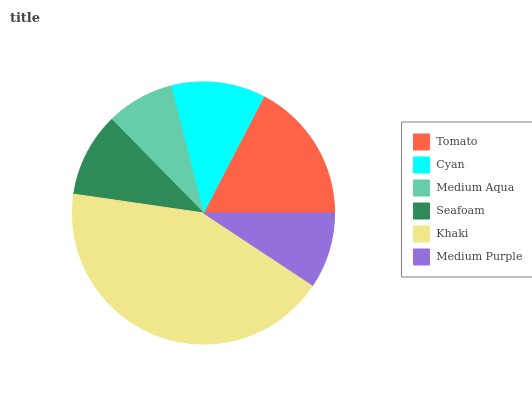Is Medium Aqua the minimum?
Answer yes or no. Yes. Is Khaki the maximum?
Answer yes or no. Yes. Is Cyan the minimum?
Answer yes or no. No. Is Cyan the maximum?
Answer yes or no. No. Is Tomato greater than Cyan?
Answer yes or no. Yes. Is Cyan less than Tomato?
Answer yes or no. Yes. Is Cyan greater than Tomato?
Answer yes or no. No. Is Tomato less than Cyan?
Answer yes or no. No. Is Cyan the high median?
Answer yes or no. Yes. Is Seafoam the low median?
Answer yes or no. Yes. Is Medium Purple the high median?
Answer yes or no. No. Is Medium Aqua the low median?
Answer yes or no. No. 